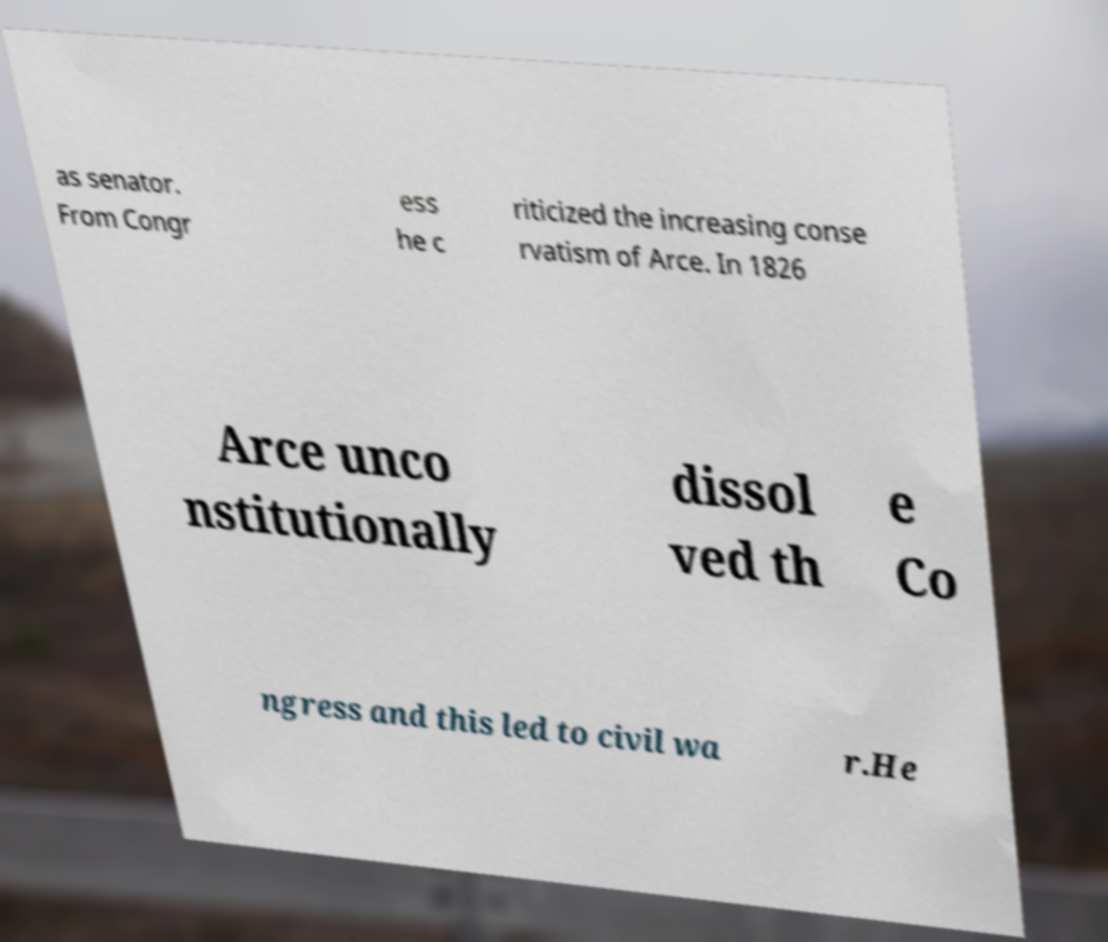What messages or text are displayed in this image? I need them in a readable, typed format. as senator. From Congr ess he c riticized the increasing conse rvatism of Arce. In 1826 Arce unco nstitutionally dissol ved th e Co ngress and this led to civil wa r.He 